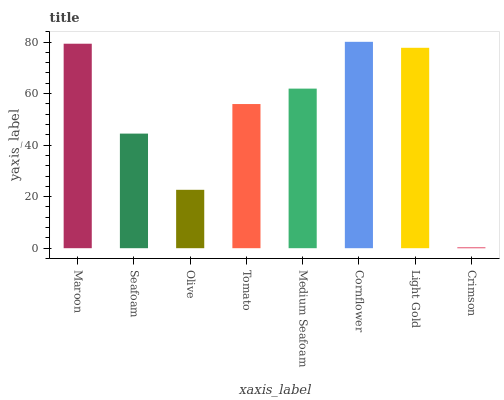Is Crimson the minimum?
Answer yes or no. Yes. Is Cornflower the maximum?
Answer yes or no. Yes. Is Seafoam the minimum?
Answer yes or no. No. Is Seafoam the maximum?
Answer yes or no. No. Is Maroon greater than Seafoam?
Answer yes or no. Yes. Is Seafoam less than Maroon?
Answer yes or no. Yes. Is Seafoam greater than Maroon?
Answer yes or no. No. Is Maroon less than Seafoam?
Answer yes or no. No. Is Medium Seafoam the high median?
Answer yes or no. Yes. Is Tomato the low median?
Answer yes or no. Yes. Is Cornflower the high median?
Answer yes or no. No. Is Medium Seafoam the low median?
Answer yes or no. No. 